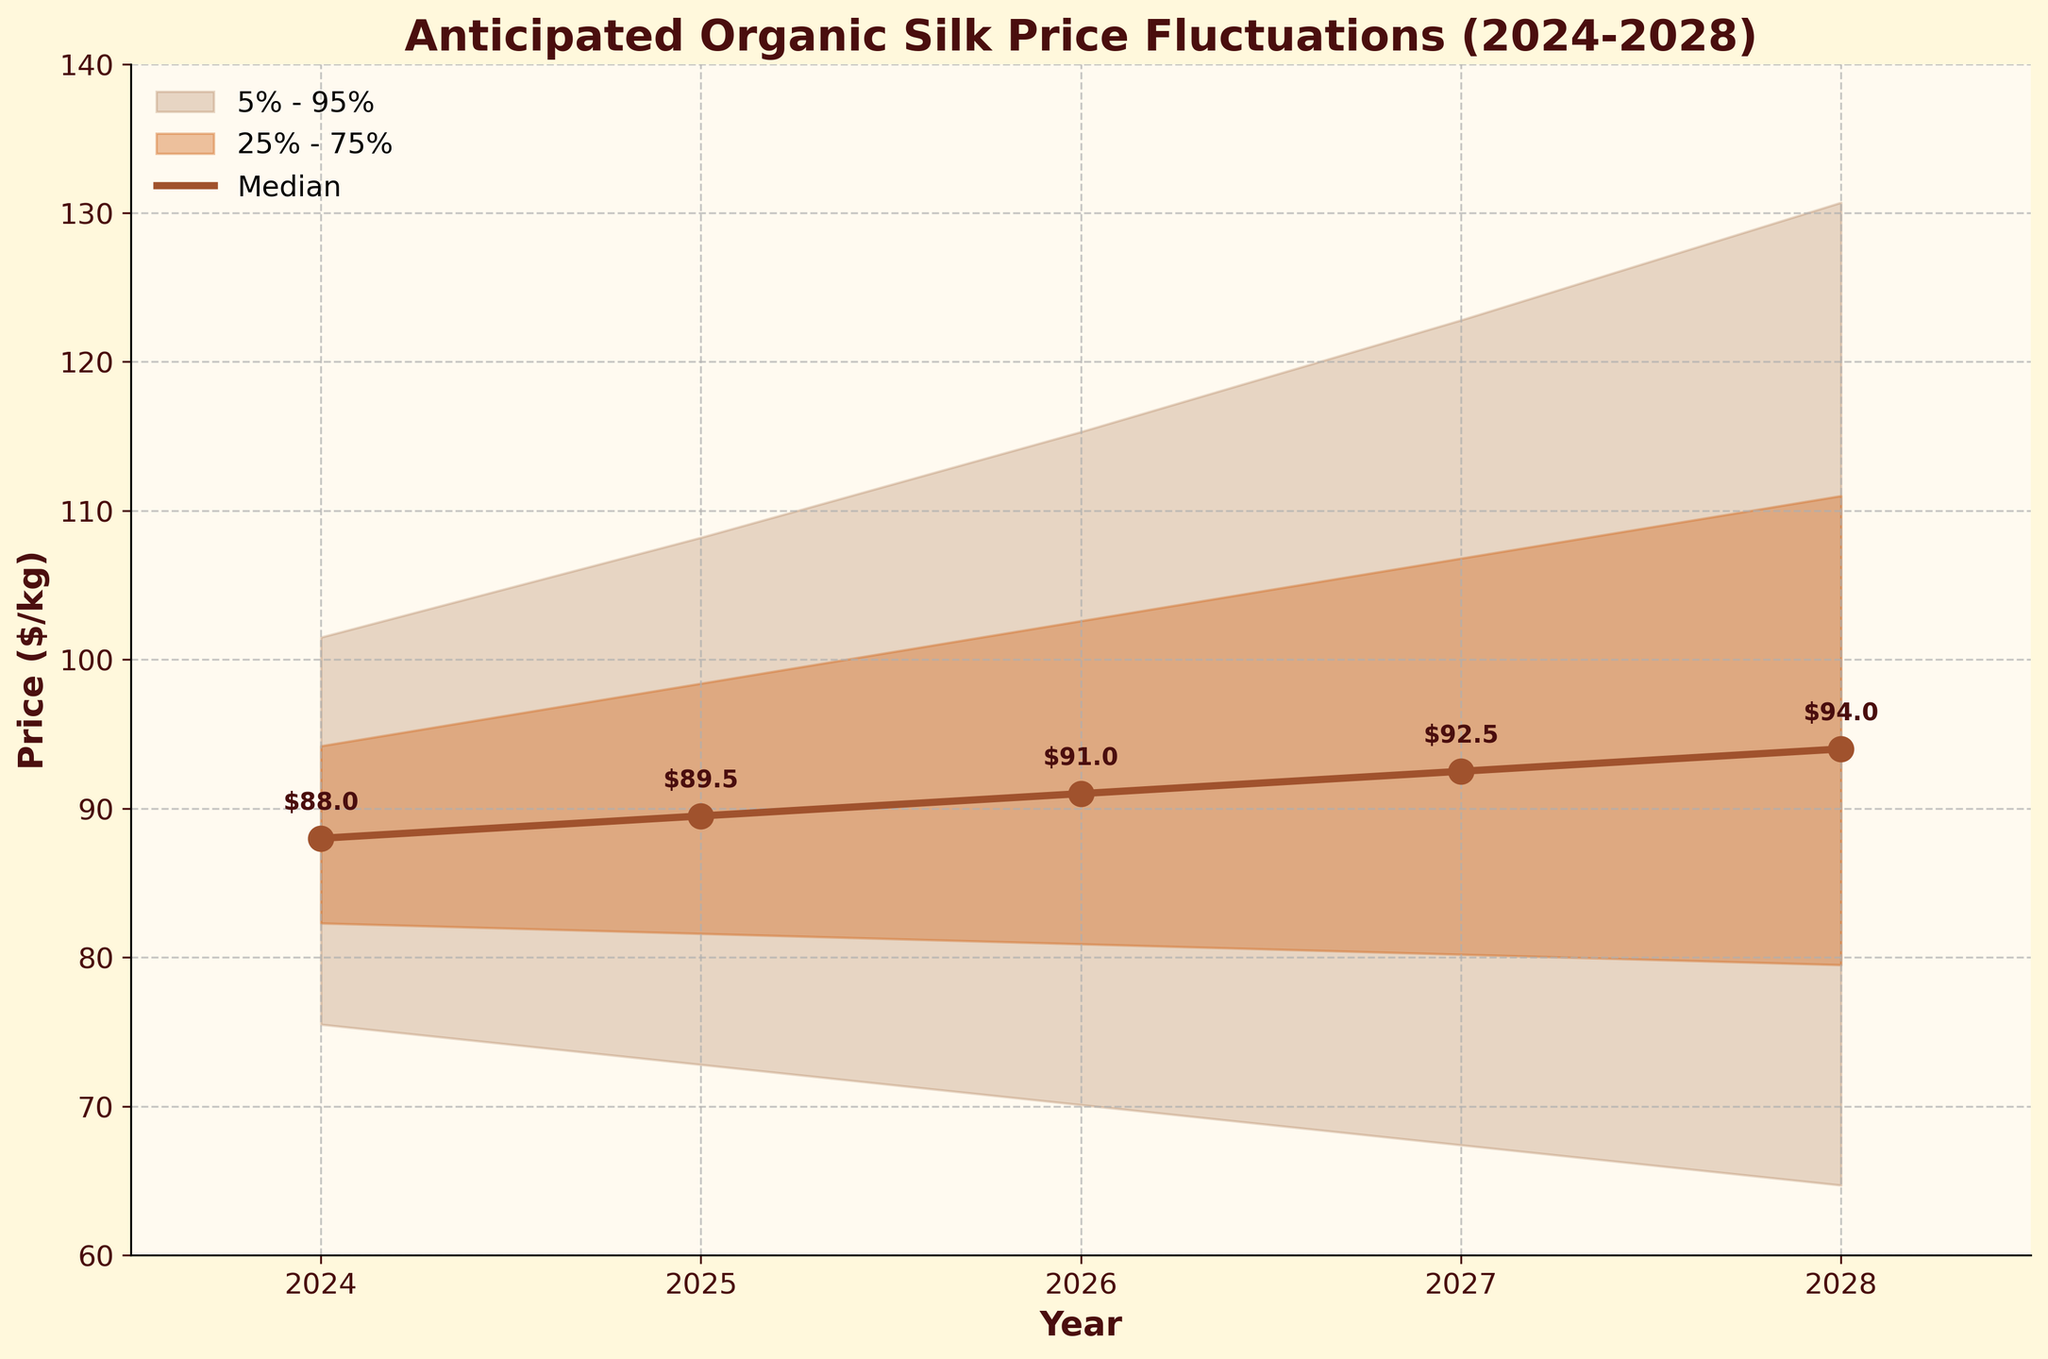How many years are displayed in the chart? By looking at the x-axis, we can see the years listed: 2024, 2025, 2026, 2027, and 2028. Counting these, there are 5 years displayed.
Answer: 5 What is the median anticipated price of organic silk in 2026? The median price for each year is indicated by the central line (or the annotations) in the figure. For the year 2026, the annotation near the line shows the median value.
Answer: $91.0 In which year is the median anticipated price expected to be the highest? To find this, compare the annotated median values for all years. The year with the highest median value is 2028 at $94.0.
Answer: 2028 How does the price range change from 2024 to 2028? Identify and compare the upper 5% and lower 5% boundaries for 2024 and 2028. In 2024, the range is from $75.5 to $101.5. In 2028, the range is from $64.7 to $130.7. The range widens as we move from 2024 to 2028.
Answer: The range widens What is the difference between the upper 5% and lower 5% for 2027? Subtract the lower 5% value from the upper 5% value for the year 2027. Using the chart, upper 5% is $122.8 and lower 5% is $67.4, calculate $122.8 - $67.4.
Answer: $55.4 Which year has the smallest spread between the upper 25% and the lower 25% boundaries? Calculate the spread (upper 25% - lower 25%) for each year. The smallest spread is where this difference is minimal. For 2024: $94.2 - $82.3 = $11.9, 2025: $98.4 - $81.6 = $16.8, 2026: $102.6 - $80.9 = $21.7, 2027: $106.8 - $80.2 = $26.6, 2028: $111.0 - $79.5 = $31.5. The smallest spread is in 2024.
Answer: 2024 How much is the median price expected to change from 2025 to 2027? Subtract the median value for 2025 from the median value for 2027. Median in 2025 is $89.5, and in 2027 is $92.5, so the change is $92.5 - $89.5.
Answer: $3.0 Which year has the largest gap between the median price and the upper 5% boundary? Calculate the gap (upper 5% - median) for each year. The largest gap will be observed. For 2024: $101.5 - $88 = $13.5, 2025: $108.2 - $89.5 = $18.7, 2026: $115.3 - $91 = $24.3, 2027: $122.8 - $92.5 = $30.3, 2028: $130.7 - $94 = $36.7. The largest gap is in 2028.
Answer: 2028 